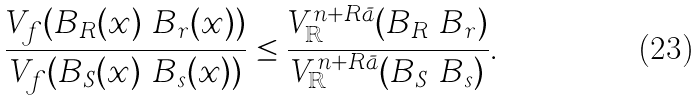<formula> <loc_0><loc_0><loc_500><loc_500>\frac { V _ { f } ( B _ { R } ( x ) \ B _ { r } ( x ) ) } { V _ { f } ( B _ { S } ( x ) \ B _ { s } ( x ) ) } & \leq \frac { V _ { \mathbb { R } } ^ { n + R \bar { a } } ( B _ { R } \ B _ { r } ) } { V _ { \mathbb { R } } ^ { n + R \bar { a } } ( B _ { S } \ B _ { s } ) } .</formula> 